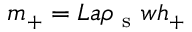<formula> <loc_0><loc_0><loc_500><loc_500>m _ { + } = L a \rho _ { s } w h _ { + }</formula> 